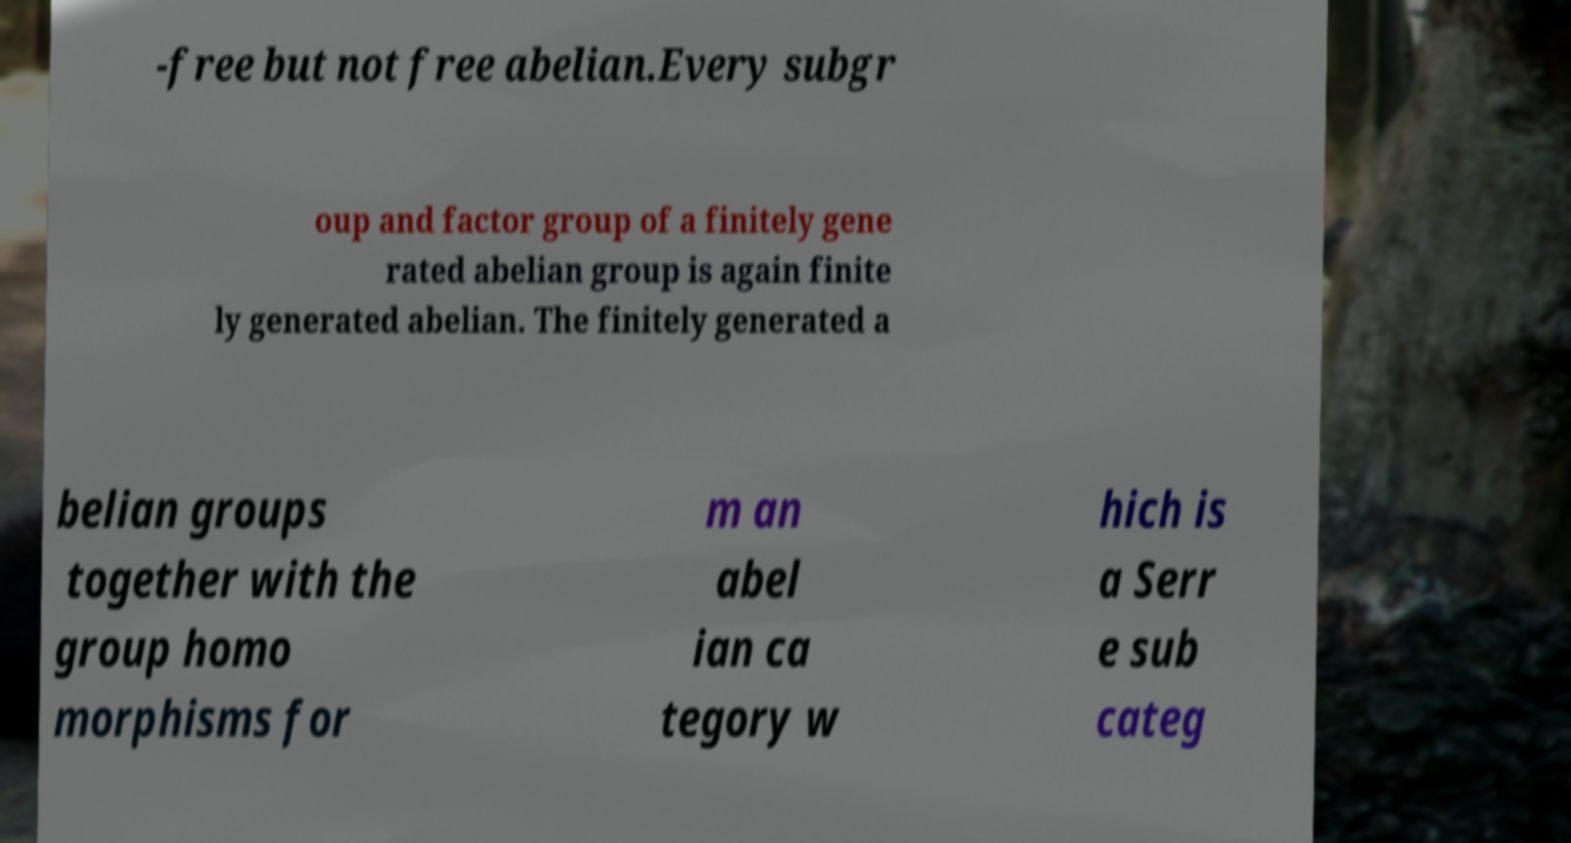Could you assist in decoding the text presented in this image and type it out clearly? -free but not free abelian.Every subgr oup and factor group of a finitely gene rated abelian group is again finite ly generated abelian. The finitely generated a belian groups together with the group homo morphisms for m an abel ian ca tegory w hich is a Serr e sub categ 